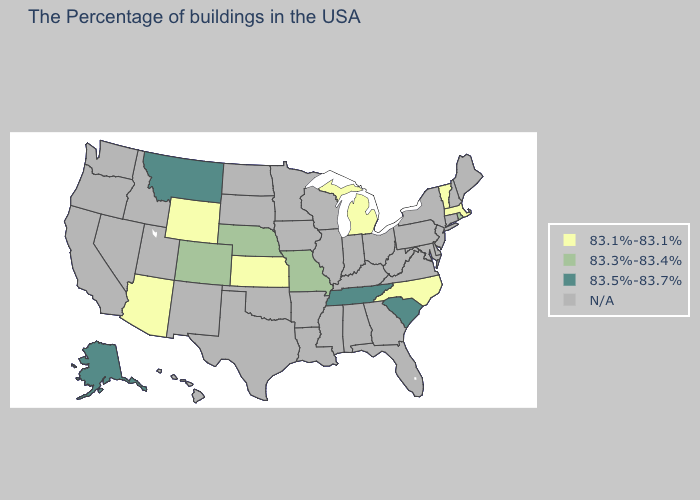What is the lowest value in the USA?
Give a very brief answer. 83.1%-83.1%. Does the first symbol in the legend represent the smallest category?
Quick response, please. Yes. Which states have the highest value in the USA?
Quick response, please. South Carolina, Tennessee, Montana, Alaska. Which states have the highest value in the USA?
Quick response, please. South Carolina, Tennessee, Montana, Alaska. Does the first symbol in the legend represent the smallest category?
Short answer required. Yes. Which states have the highest value in the USA?
Keep it brief. South Carolina, Tennessee, Montana, Alaska. What is the lowest value in the USA?
Quick response, please. 83.1%-83.1%. Which states have the lowest value in the USA?
Concise answer only. Massachusetts, Vermont, North Carolina, Michigan, Kansas, Wyoming, Arizona. Is the legend a continuous bar?
Answer briefly. No. Does Kansas have the lowest value in the USA?
Write a very short answer. Yes. Name the states that have a value in the range N/A?
Quick response, please. Maine, New Hampshire, Connecticut, New York, New Jersey, Delaware, Maryland, Pennsylvania, Virginia, West Virginia, Ohio, Florida, Georgia, Kentucky, Indiana, Alabama, Wisconsin, Illinois, Mississippi, Louisiana, Arkansas, Minnesota, Iowa, Oklahoma, Texas, South Dakota, North Dakota, New Mexico, Utah, Idaho, Nevada, California, Washington, Oregon, Hawaii. Name the states that have a value in the range 83.5%-83.7%?
Give a very brief answer. South Carolina, Tennessee, Montana, Alaska. 